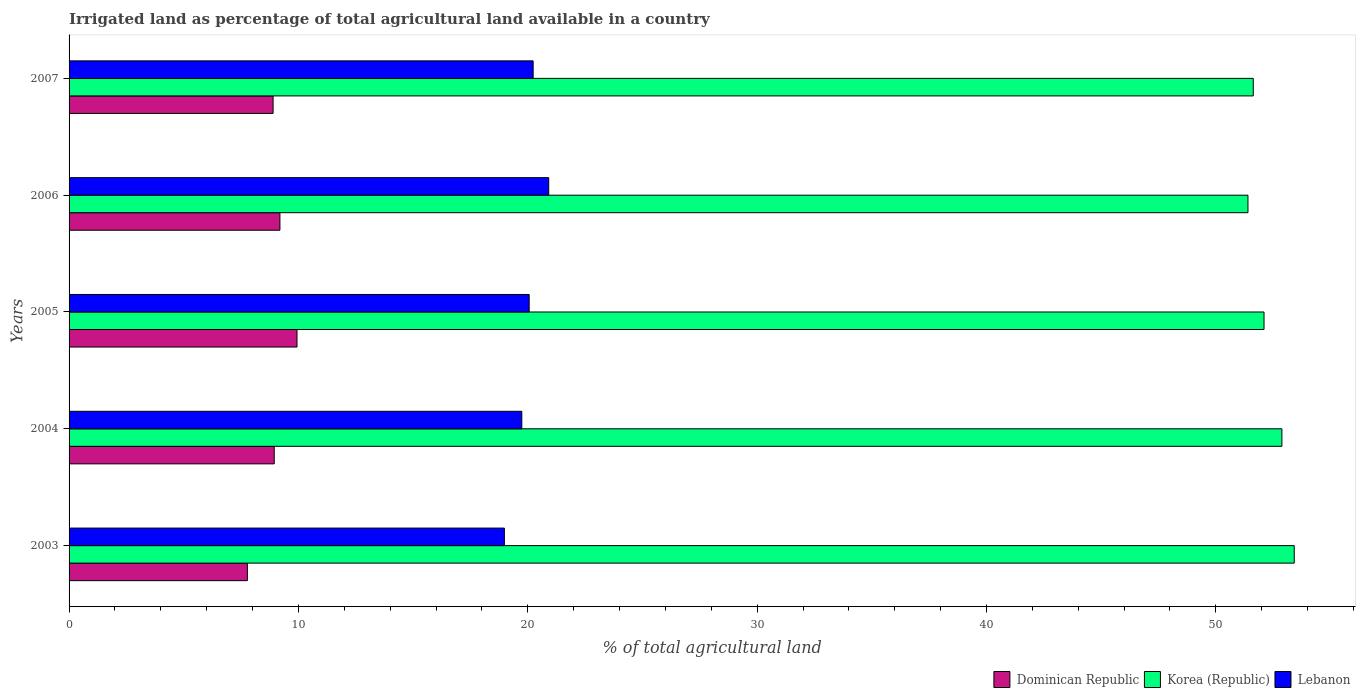Are the number of bars on each tick of the Y-axis equal?
Your answer should be compact. Yes. What is the percentage of irrigated land in Dominican Republic in 2007?
Make the answer very short. 8.9. Across all years, what is the maximum percentage of irrigated land in Lebanon?
Keep it short and to the point. 20.91. Across all years, what is the minimum percentage of irrigated land in Lebanon?
Provide a short and direct response. 18.98. In which year was the percentage of irrigated land in Lebanon minimum?
Make the answer very short. 2003. What is the total percentage of irrigated land in Dominican Republic in the graph?
Your answer should be very brief. 44.75. What is the difference between the percentage of irrigated land in Korea (Republic) in 2006 and that in 2007?
Give a very brief answer. -0.23. What is the difference between the percentage of irrigated land in Lebanon in 2006 and the percentage of irrigated land in Korea (Republic) in 2007?
Your answer should be compact. -30.72. What is the average percentage of irrigated land in Korea (Republic) per year?
Provide a succinct answer. 52.29. In the year 2004, what is the difference between the percentage of irrigated land in Dominican Republic and percentage of irrigated land in Lebanon?
Your answer should be very brief. -10.79. In how many years, is the percentage of irrigated land in Korea (Republic) greater than 10 %?
Give a very brief answer. 5. What is the ratio of the percentage of irrigated land in Lebanon in 2004 to that in 2006?
Offer a very short reply. 0.94. What is the difference between the highest and the second highest percentage of irrigated land in Dominican Republic?
Make the answer very short. 0.74. What is the difference between the highest and the lowest percentage of irrigated land in Lebanon?
Your answer should be very brief. 1.93. In how many years, is the percentage of irrigated land in Dominican Republic greater than the average percentage of irrigated land in Dominican Republic taken over all years?
Provide a succinct answer. 2. What does the 3rd bar from the bottom in 2003 represents?
Keep it short and to the point. Lebanon. How many years are there in the graph?
Provide a short and direct response. 5. Where does the legend appear in the graph?
Offer a terse response. Bottom right. How many legend labels are there?
Offer a very short reply. 3. How are the legend labels stacked?
Your response must be concise. Horizontal. What is the title of the graph?
Provide a succinct answer. Irrigated land as percentage of total agricultural land available in a country. Does "Monaco" appear as one of the legend labels in the graph?
Your response must be concise. No. What is the label or title of the X-axis?
Keep it short and to the point. % of total agricultural land. What is the % of total agricultural land in Dominican Republic in 2003?
Your answer should be very brief. 7.77. What is the % of total agricultural land of Korea (Republic) in 2003?
Offer a terse response. 53.42. What is the % of total agricultural land in Lebanon in 2003?
Give a very brief answer. 18.98. What is the % of total agricultural land in Dominican Republic in 2004?
Ensure brevity in your answer.  8.94. What is the % of total agricultural land in Korea (Republic) in 2004?
Provide a short and direct response. 52.88. What is the % of total agricultural land in Lebanon in 2004?
Offer a terse response. 19.74. What is the % of total agricultural land in Dominican Republic in 2005?
Offer a terse response. 9.94. What is the % of total agricultural land in Korea (Republic) in 2005?
Make the answer very short. 52.1. What is the % of total agricultural land of Lebanon in 2005?
Provide a short and direct response. 20.06. What is the % of total agricultural land of Dominican Republic in 2006?
Make the answer very short. 9.19. What is the % of total agricultural land in Korea (Republic) in 2006?
Keep it short and to the point. 51.4. What is the % of total agricultural land of Lebanon in 2006?
Give a very brief answer. 20.91. What is the % of total agricultural land in Dominican Republic in 2007?
Provide a short and direct response. 8.9. What is the % of total agricultural land in Korea (Republic) in 2007?
Your response must be concise. 51.63. What is the % of total agricultural land of Lebanon in 2007?
Give a very brief answer. 20.23. Across all years, what is the maximum % of total agricultural land in Dominican Republic?
Your answer should be very brief. 9.94. Across all years, what is the maximum % of total agricultural land of Korea (Republic)?
Ensure brevity in your answer.  53.42. Across all years, what is the maximum % of total agricultural land of Lebanon?
Your answer should be very brief. 20.91. Across all years, what is the minimum % of total agricultural land in Dominican Republic?
Provide a succinct answer. 7.77. Across all years, what is the minimum % of total agricultural land in Korea (Republic)?
Offer a terse response. 51.4. Across all years, what is the minimum % of total agricultural land of Lebanon?
Provide a short and direct response. 18.98. What is the total % of total agricultural land of Dominican Republic in the graph?
Offer a very short reply. 44.75. What is the total % of total agricultural land in Korea (Republic) in the graph?
Provide a short and direct response. 261.43. What is the total % of total agricultural land in Lebanon in the graph?
Offer a terse response. 99.93. What is the difference between the % of total agricultural land of Dominican Republic in 2003 and that in 2004?
Offer a very short reply. -1.17. What is the difference between the % of total agricultural land of Korea (Republic) in 2003 and that in 2004?
Your response must be concise. 0.54. What is the difference between the % of total agricultural land in Lebanon in 2003 and that in 2004?
Give a very brief answer. -0.76. What is the difference between the % of total agricultural land of Dominican Republic in 2003 and that in 2005?
Offer a very short reply. -2.16. What is the difference between the % of total agricultural land of Korea (Republic) in 2003 and that in 2005?
Your answer should be compact. 1.32. What is the difference between the % of total agricultural land in Lebanon in 2003 and that in 2005?
Keep it short and to the point. -1.08. What is the difference between the % of total agricultural land in Dominican Republic in 2003 and that in 2006?
Ensure brevity in your answer.  -1.42. What is the difference between the % of total agricultural land of Korea (Republic) in 2003 and that in 2006?
Keep it short and to the point. 2.02. What is the difference between the % of total agricultural land in Lebanon in 2003 and that in 2006?
Ensure brevity in your answer.  -1.93. What is the difference between the % of total agricultural land in Dominican Republic in 2003 and that in 2007?
Offer a very short reply. -1.12. What is the difference between the % of total agricultural land in Korea (Republic) in 2003 and that in 2007?
Your response must be concise. 1.79. What is the difference between the % of total agricultural land of Lebanon in 2003 and that in 2007?
Make the answer very short. -1.25. What is the difference between the % of total agricultural land of Dominican Republic in 2004 and that in 2005?
Give a very brief answer. -0.99. What is the difference between the % of total agricultural land in Korea (Republic) in 2004 and that in 2005?
Offer a terse response. 0.78. What is the difference between the % of total agricultural land in Lebanon in 2004 and that in 2005?
Give a very brief answer. -0.32. What is the difference between the % of total agricultural land of Dominican Republic in 2004 and that in 2006?
Keep it short and to the point. -0.25. What is the difference between the % of total agricultural land of Korea (Republic) in 2004 and that in 2006?
Your response must be concise. 1.48. What is the difference between the % of total agricultural land in Lebanon in 2004 and that in 2006?
Ensure brevity in your answer.  -1.17. What is the difference between the % of total agricultural land in Dominican Republic in 2004 and that in 2007?
Your response must be concise. 0.05. What is the difference between the % of total agricultural land of Korea (Republic) in 2004 and that in 2007?
Your answer should be very brief. 1.25. What is the difference between the % of total agricultural land in Lebanon in 2004 and that in 2007?
Ensure brevity in your answer.  -0.49. What is the difference between the % of total agricultural land in Dominican Republic in 2005 and that in 2006?
Your response must be concise. 0.74. What is the difference between the % of total agricultural land of Korea (Republic) in 2005 and that in 2006?
Your answer should be compact. 0.7. What is the difference between the % of total agricultural land of Lebanon in 2005 and that in 2006?
Offer a terse response. -0.85. What is the difference between the % of total agricultural land in Dominican Republic in 2005 and that in 2007?
Provide a short and direct response. 1.04. What is the difference between the % of total agricultural land of Korea (Republic) in 2005 and that in 2007?
Offer a terse response. 0.47. What is the difference between the % of total agricultural land in Lebanon in 2005 and that in 2007?
Your answer should be compact. -0.17. What is the difference between the % of total agricultural land of Dominican Republic in 2006 and that in 2007?
Keep it short and to the point. 0.3. What is the difference between the % of total agricultural land of Korea (Republic) in 2006 and that in 2007?
Your answer should be very brief. -0.23. What is the difference between the % of total agricultural land of Lebanon in 2006 and that in 2007?
Give a very brief answer. 0.68. What is the difference between the % of total agricultural land of Dominican Republic in 2003 and the % of total agricultural land of Korea (Republic) in 2004?
Give a very brief answer. -45.1. What is the difference between the % of total agricultural land in Dominican Republic in 2003 and the % of total agricultural land in Lebanon in 2004?
Provide a succinct answer. -11.97. What is the difference between the % of total agricultural land of Korea (Republic) in 2003 and the % of total agricultural land of Lebanon in 2004?
Provide a short and direct response. 33.68. What is the difference between the % of total agricultural land of Dominican Republic in 2003 and the % of total agricultural land of Korea (Republic) in 2005?
Provide a succinct answer. -44.33. What is the difference between the % of total agricultural land in Dominican Republic in 2003 and the % of total agricultural land in Lebanon in 2005?
Ensure brevity in your answer.  -12.29. What is the difference between the % of total agricultural land of Korea (Republic) in 2003 and the % of total agricultural land of Lebanon in 2005?
Offer a terse response. 33.36. What is the difference between the % of total agricultural land in Dominican Republic in 2003 and the % of total agricultural land in Korea (Republic) in 2006?
Keep it short and to the point. -43.63. What is the difference between the % of total agricultural land of Dominican Republic in 2003 and the % of total agricultural land of Lebanon in 2006?
Your answer should be compact. -13.14. What is the difference between the % of total agricultural land of Korea (Republic) in 2003 and the % of total agricultural land of Lebanon in 2006?
Your answer should be compact. 32.5. What is the difference between the % of total agricultural land of Dominican Republic in 2003 and the % of total agricultural land of Korea (Republic) in 2007?
Make the answer very short. -43.86. What is the difference between the % of total agricultural land in Dominican Republic in 2003 and the % of total agricultural land in Lebanon in 2007?
Your answer should be very brief. -12.46. What is the difference between the % of total agricultural land in Korea (Republic) in 2003 and the % of total agricultural land in Lebanon in 2007?
Your answer should be compact. 33.18. What is the difference between the % of total agricultural land of Dominican Republic in 2004 and the % of total agricultural land of Korea (Republic) in 2005?
Make the answer very short. -43.16. What is the difference between the % of total agricultural land of Dominican Republic in 2004 and the % of total agricultural land of Lebanon in 2005?
Keep it short and to the point. -11.12. What is the difference between the % of total agricultural land of Korea (Republic) in 2004 and the % of total agricultural land of Lebanon in 2005?
Keep it short and to the point. 32.82. What is the difference between the % of total agricultural land in Dominican Republic in 2004 and the % of total agricultural land in Korea (Republic) in 2006?
Ensure brevity in your answer.  -42.45. What is the difference between the % of total agricultural land of Dominican Republic in 2004 and the % of total agricultural land of Lebanon in 2006?
Give a very brief answer. -11.97. What is the difference between the % of total agricultural land of Korea (Republic) in 2004 and the % of total agricultural land of Lebanon in 2006?
Offer a terse response. 31.97. What is the difference between the % of total agricultural land in Dominican Republic in 2004 and the % of total agricultural land in Korea (Republic) in 2007?
Your answer should be very brief. -42.69. What is the difference between the % of total agricultural land of Dominican Republic in 2004 and the % of total agricultural land of Lebanon in 2007?
Provide a short and direct response. -11.29. What is the difference between the % of total agricultural land of Korea (Republic) in 2004 and the % of total agricultural land of Lebanon in 2007?
Give a very brief answer. 32.65. What is the difference between the % of total agricultural land of Dominican Republic in 2005 and the % of total agricultural land of Korea (Republic) in 2006?
Provide a short and direct response. -41.46. What is the difference between the % of total agricultural land of Dominican Republic in 2005 and the % of total agricultural land of Lebanon in 2006?
Give a very brief answer. -10.98. What is the difference between the % of total agricultural land in Korea (Republic) in 2005 and the % of total agricultural land in Lebanon in 2006?
Your response must be concise. 31.19. What is the difference between the % of total agricultural land of Dominican Republic in 2005 and the % of total agricultural land of Korea (Republic) in 2007?
Provide a succinct answer. -41.69. What is the difference between the % of total agricultural land of Dominican Republic in 2005 and the % of total agricultural land of Lebanon in 2007?
Ensure brevity in your answer.  -10.3. What is the difference between the % of total agricultural land in Korea (Republic) in 2005 and the % of total agricultural land in Lebanon in 2007?
Keep it short and to the point. 31.87. What is the difference between the % of total agricultural land of Dominican Republic in 2006 and the % of total agricultural land of Korea (Republic) in 2007?
Ensure brevity in your answer.  -42.44. What is the difference between the % of total agricultural land of Dominican Republic in 2006 and the % of total agricultural land of Lebanon in 2007?
Your answer should be very brief. -11.04. What is the difference between the % of total agricultural land of Korea (Republic) in 2006 and the % of total agricultural land of Lebanon in 2007?
Make the answer very short. 31.17. What is the average % of total agricultural land of Dominican Republic per year?
Make the answer very short. 8.95. What is the average % of total agricultural land of Korea (Republic) per year?
Your answer should be compact. 52.29. What is the average % of total agricultural land in Lebanon per year?
Your response must be concise. 19.99. In the year 2003, what is the difference between the % of total agricultural land of Dominican Republic and % of total agricultural land of Korea (Republic)?
Give a very brief answer. -45.64. In the year 2003, what is the difference between the % of total agricultural land of Dominican Republic and % of total agricultural land of Lebanon?
Your response must be concise. -11.21. In the year 2003, what is the difference between the % of total agricultural land in Korea (Republic) and % of total agricultural land in Lebanon?
Make the answer very short. 34.44. In the year 2004, what is the difference between the % of total agricultural land of Dominican Republic and % of total agricultural land of Korea (Republic)?
Give a very brief answer. -43.93. In the year 2004, what is the difference between the % of total agricultural land in Dominican Republic and % of total agricultural land in Lebanon?
Provide a succinct answer. -10.79. In the year 2004, what is the difference between the % of total agricultural land of Korea (Republic) and % of total agricultural land of Lebanon?
Make the answer very short. 33.14. In the year 2005, what is the difference between the % of total agricultural land of Dominican Republic and % of total agricultural land of Korea (Republic)?
Make the answer very short. -42.16. In the year 2005, what is the difference between the % of total agricultural land of Dominican Republic and % of total agricultural land of Lebanon?
Give a very brief answer. -10.12. In the year 2005, what is the difference between the % of total agricultural land of Korea (Republic) and % of total agricultural land of Lebanon?
Provide a short and direct response. 32.04. In the year 2006, what is the difference between the % of total agricultural land of Dominican Republic and % of total agricultural land of Korea (Republic)?
Make the answer very short. -42.21. In the year 2006, what is the difference between the % of total agricultural land of Dominican Republic and % of total agricultural land of Lebanon?
Provide a short and direct response. -11.72. In the year 2006, what is the difference between the % of total agricultural land in Korea (Republic) and % of total agricultural land in Lebanon?
Ensure brevity in your answer.  30.49. In the year 2007, what is the difference between the % of total agricultural land in Dominican Republic and % of total agricultural land in Korea (Republic)?
Provide a succinct answer. -42.74. In the year 2007, what is the difference between the % of total agricultural land of Dominican Republic and % of total agricultural land of Lebanon?
Your answer should be very brief. -11.34. In the year 2007, what is the difference between the % of total agricultural land in Korea (Republic) and % of total agricultural land in Lebanon?
Give a very brief answer. 31.4. What is the ratio of the % of total agricultural land of Dominican Republic in 2003 to that in 2004?
Offer a very short reply. 0.87. What is the ratio of the % of total agricultural land of Korea (Republic) in 2003 to that in 2004?
Offer a terse response. 1.01. What is the ratio of the % of total agricultural land of Lebanon in 2003 to that in 2004?
Provide a succinct answer. 0.96. What is the ratio of the % of total agricultural land in Dominican Republic in 2003 to that in 2005?
Your response must be concise. 0.78. What is the ratio of the % of total agricultural land in Korea (Republic) in 2003 to that in 2005?
Ensure brevity in your answer.  1.03. What is the ratio of the % of total agricultural land of Lebanon in 2003 to that in 2005?
Offer a terse response. 0.95. What is the ratio of the % of total agricultural land in Dominican Republic in 2003 to that in 2006?
Your answer should be very brief. 0.85. What is the ratio of the % of total agricultural land of Korea (Republic) in 2003 to that in 2006?
Your response must be concise. 1.04. What is the ratio of the % of total agricultural land of Lebanon in 2003 to that in 2006?
Keep it short and to the point. 0.91. What is the ratio of the % of total agricultural land of Dominican Republic in 2003 to that in 2007?
Give a very brief answer. 0.87. What is the ratio of the % of total agricultural land of Korea (Republic) in 2003 to that in 2007?
Offer a terse response. 1.03. What is the ratio of the % of total agricultural land in Lebanon in 2003 to that in 2007?
Your response must be concise. 0.94. What is the ratio of the % of total agricultural land in Dominican Republic in 2004 to that in 2005?
Ensure brevity in your answer.  0.9. What is the ratio of the % of total agricultural land in Lebanon in 2004 to that in 2005?
Offer a terse response. 0.98. What is the ratio of the % of total agricultural land in Korea (Republic) in 2004 to that in 2006?
Offer a terse response. 1.03. What is the ratio of the % of total agricultural land of Lebanon in 2004 to that in 2006?
Provide a short and direct response. 0.94. What is the ratio of the % of total agricultural land of Dominican Republic in 2004 to that in 2007?
Your answer should be very brief. 1.01. What is the ratio of the % of total agricultural land in Korea (Republic) in 2004 to that in 2007?
Ensure brevity in your answer.  1.02. What is the ratio of the % of total agricultural land in Lebanon in 2004 to that in 2007?
Provide a succinct answer. 0.98. What is the ratio of the % of total agricultural land in Dominican Republic in 2005 to that in 2006?
Your response must be concise. 1.08. What is the ratio of the % of total agricultural land of Korea (Republic) in 2005 to that in 2006?
Ensure brevity in your answer.  1.01. What is the ratio of the % of total agricultural land in Lebanon in 2005 to that in 2006?
Offer a very short reply. 0.96. What is the ratio of the % of total agricultural land in Dominican Republic in 2005 to that in 2007?
Give a very brief answer. 1.12. What is the ratio of the % of total agricultural land in Korea (Republic) in 2005 to that in 2007?
Your response must be concise. 1.01. What is the ratio of the % of total agricultural land in Lebanon in 2005 to that in 2007?
Offer a terse response. 0.99. What is the ratio of the % of total agricultural land of Dominican Republic in 2006 to that in 2007?
Provide a succinct answer. 1.03. What is the ratio of the % of total agricultural land of Korea (Republic) in 2006 to that in 2007?
Ensure brevity in your answer.  1. What is the ratio of the % of total agricultural land in Lebanon in 2006 to that in 2007?
Provide a succinct answer. 1.03. What is the difference between the highest and the second highest % of total agricultural land in Dominican Republic?
Provide a succinct answer. 0.74. What is the difference between the highest and the second highest % of total agricultural land of Korea (Republic)?
Offer a very short reply. 0.54. What is the difference between the highest and the second highest % of total agricultural land of Lebanon?
Offer a terse response. 0.68. What is the difference between the highest and the lowest % of total agricultural land in Dominican Republic?
Your answer should be compact. 2.16. What is the difference between the highest and the lowest % of total agricultural land in Korea (Republic)?
Your answer should be compact. 2.02. What is the difference between the highest and the lowest % of total agricultural land in Lebanon?
Keep it short and to the point. 1.93. 